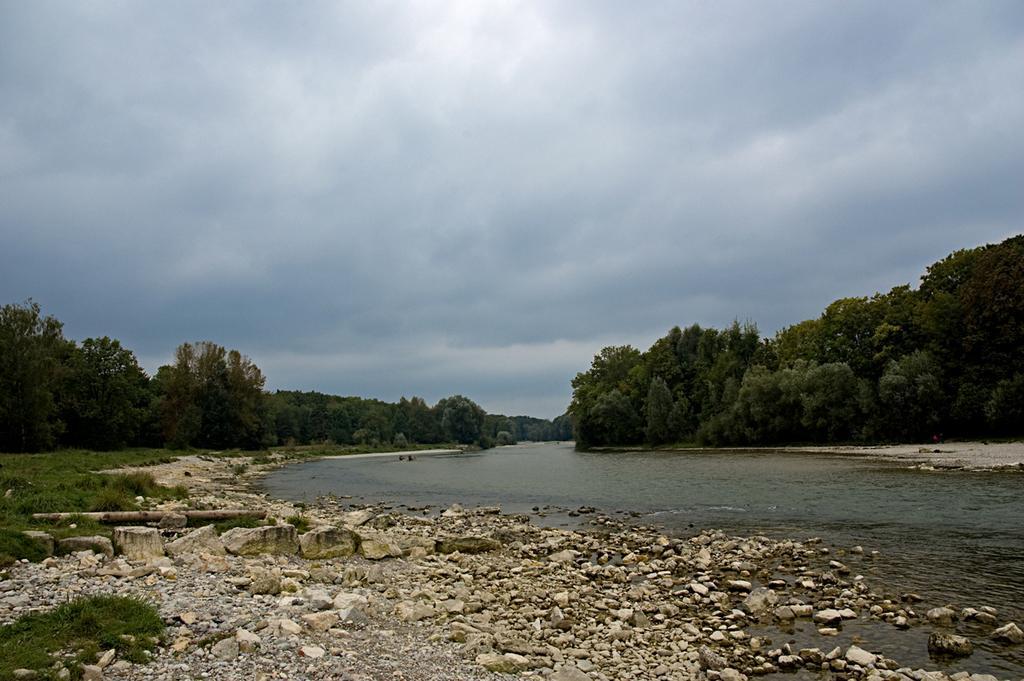Describe this image in one or two sentences. This picture shows few trees, stones and rocks and we see water and a cloudy sky and grass on the ground. 